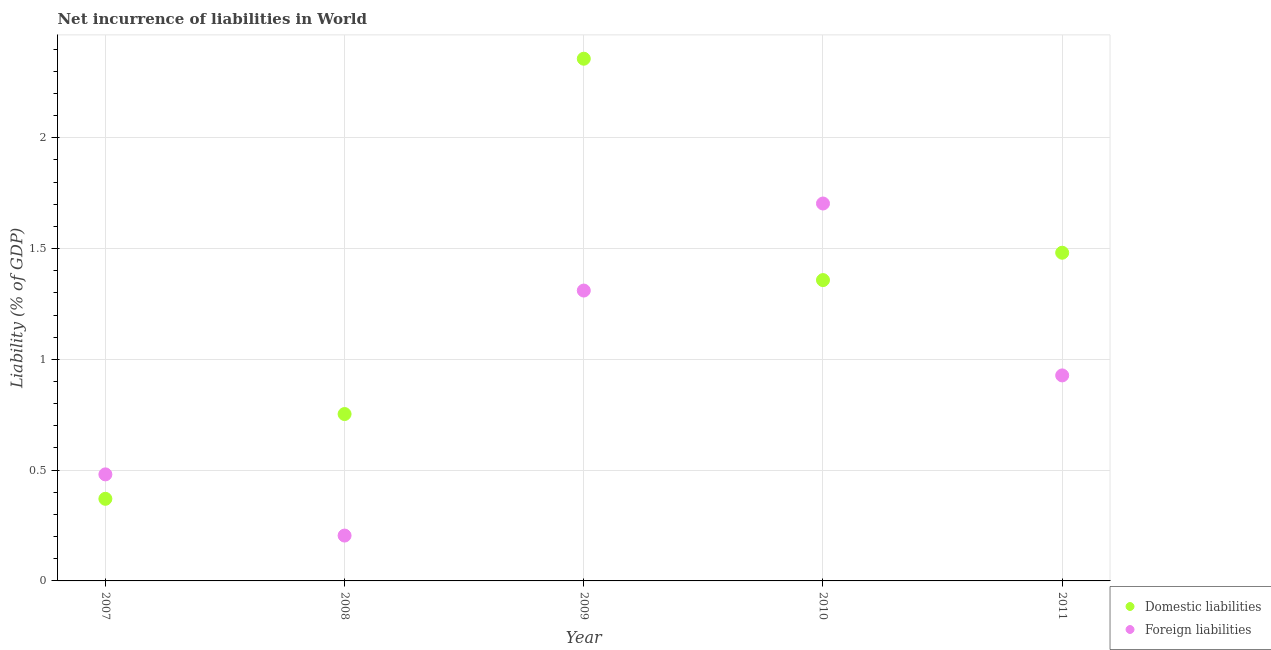What is the incurrence of domestic liabilities in 2010?
Provide a short and direct response. 1.36. Across all years, what is the maximum incurrence of foreign liabilities?
Provide a succinct answer. 1.7. Across all years, what is the minimum incurrence of domestic liabilities?
Your answer should be compact. 0.37. In which year was the incurrence of domestic liabilities minimum?
Keep it short and to the point. 2007. What is the total incurrence of foreign liabilities in the graph?
Give a very brief answer. 4.63. What is the difference between the incurrence of domestic liabilities in 2007 and that in 2010?
Offer a very short reply. -0.99. What is the difference between the incurrence of foreign liabilities in 2010 and the incurrence of domestic liabilities in 2008?
Your answer should be very brief. 0.95. What is the average incurrence of domestic liabilities per year?
Your answer should be very brief. 1.26. In the year 2011, what is the difference between the incurrence of domestic liabilities and incurrence of foreign liabilities?
Your answer should be very brief. 0.55. In how many years, is the incurrence of foreign liabilities greater than 2 %?
Offer a very short reply. 0. What is the ratio of the incurrence of domestic liabilities in 2007 to that in 2011?
Provide a succinct answer. 0.25. What is the difference between the highest and the second highest incurrence of foreign liabilities?
Your answer should be very brief. 0.39. What is the difference between the highest and the lowest incurrence of foreign liabilities?
Offer a terse response. 1.5. Is the sum of the incurrence of foreign liabilities in 2009 and 2011 greater than the maximum incurrence of domestic liabilities across all years?
Provide a succinct answer. No. Does the incurrence of foreign liabilities monotonically increase over the years?
Keep it short and to the point. No. How many dotlines are there?
Give a very brief answer. 2. How many years are there in the graph?
Make the answer very short. 5. Are the values on the major ticks of Y-axis written in scientific E-notation?
Provide a short and direct response. No. Does the graph contain any zero values?
Provide a succinct answer. No. Where does the legend appear in the graph?
Your response must be concise. Bottom right. How many legend labels are there?
Provide a succinct answer. 2. What is the title of the graph?
Make the answer very short. Net incurrence of liabilities in World. What is the label or title of the Y-axis?
Keep it short and to the point. Liability (% of GDP). What is the Liability (% of GDP) in Domestic liabilities in 2007?
Provide a succinct answer. 0.37. What is the Liability (% of GDP) in Foreign liabilities in 2007?
Keep it short and to the point. 0.48. What is the Liability (% of GDP) of Domestic liabilities in 2008?
Keep it short and to the point. 0.75. What is the Liability (% of GDP) in Foreign liabilities in 2008?
Offer a terse response. 0.2. What is the Liability (% of GDP) of Domestic liabilities in 2009?
Your answer should be very brief. 2.36. What is the Liability (% of GDP) in Foreign liabilities in 2009?
Your answer should be very brief. 1.31. What is the Liability (% of GDP) of Domestic liabilities in 2010?
Your response must be concise. 1.36. What is the Liability (% of GDP) of Foreign liabilities in 2010?
Your answer should be very brief. 1.7. What is the Liability (% of GDP) in Domestic liabilities in 2011?
Your response must be concise. 1.48. What is the Liability (% of GDP) of Foreign liabilities in 2011?
Make the answer very short. 0.93. Across all years, what is the maximum Liability (% of GDP) in Domestic liabilities?
Your answer should be compact. 2.36. Across all years, what is the maximum Liability (% of GDP) of Foreign liabilities?
Offer a very short reply. 1.7. Across all years, what is the minimum Liability (% of GDP) of Domestic liabilities?
Make the answer very short. 0.37. Across all years, what is the minimum Liability (% of GDP) in Foreign liabilities?
Give a very brief answer. 0.2. What is the total Liability (% of GDP) of Domestic liabilities in the graph?
Keep it short and to the point. 6.32. What is the total Liability (% of GDP) of Foreign liabilities in the graph?
Offer a very short reply. 4.63. What is the difference between the Liability (% of GDP) of Domestic liabilities in 2007 and that in 2008?
Offer a very short reply. -0.38. What is the difference between the Liability (% of GDP) in Foreign liabilities in 2007 and that in 2008?
Your answer should be very brief. 0.28. What is the difference between the Liability (% of GDP) of Domestic liabilities in 2007 and that in 2009?
Ensure brevity in your answer.  -1.99. What is the difference between the Liability (% of GDP) in Foreign liabilities in 2007 and that in 2009?
Offer a terse response. -0.83. What is the difference between the Liability (% of GDP) of Domestic liabilities in 2007 and that in 2010?
Offer a terse response. -0.99. What is the difference between the Liability (% of GDP) in Foreign liabilities in 2007 and that in 2010?
Give a very brief answer. -1.22. What is the difference between the Liability (% of GDP) of Domestic liabilities in 2007 and that in 2011?
Ensure brevity in your answer.  -1.11. What is the difference between the Liability (% of GDP) of Foreign liabilities in 2007 and that in 2011?
Provide a short and direct response. -0.45. What is the difference between the Liability (% of GDP) in Domestic liabilities in 2008 and that in 2009?
Your response must be concise. -1.6. What is the difference between the Liability (% of GDP) of Foreign liabilities in 2008 and that in 2009?
Provide a short and direct response. -1.11. What is the difference between the Liability (% of GDP) of Domestic liabilities in 2008 and that in 2010?
Your response must be concise. -0.6. What is the difference between the Liability (% of GDP) in Foreign liabilities in 2008 and that in 2010?
Your answer should be very brief. -1.5. What is the difference between the Liability (% of GDP) in Domestic liabilities in 2008 and that in 2011?
Offer a very short reply. -0.73. What is the difference between the Liability (% of GDP) in Foreign liabilities in 2008 and that in 2011?
Ensure brevity in your answer.  -0.72. What is the difference between the Liability (% of GDP) of Foreign liabilities in 2009 and that in 2010?
Your answer should be very brief. -0.39. What is the difference between the Liability (% of GDP) in Domestic liabilities in 2009 and that in 2011?
Give a very brief answer. 0.88. What is the difference between the Liability (% of GDP) in Foreign liabilities in 2009 and that in 2011?
Keep it short and to the point. 0.38. What is the difference between the Liability (% of GDP) in Domestic liabilities in 2010 and that in 2011?
Provide a succinct answer. -0.12. What is the difference between the Liability (% of GDP) in Foreign liabilities in 2010 and that in 2011?
Your answer should be compact. 0.78. What is the difference between the Liability (% of GDP) of Domestic liabilities in 2007 and the Liability (% of GDP) of Foreign liabilities in 2008?
Provide a succinct answer. 0.17. What is the difference between the Liability (% of GDP) of Domestic liabilities in 2007 and the Liability (% of GDP) of Foreign liabilities in 2009?
Your answer should be compact. -0.94. What is the difference between the Liability (% of GDP) of Domestic liabilities in 2007 and the Liability (% of GDP) of Foreign liabilities in 2010?
Your response must be concise. -1.33. What is the difference between the Liability (% of GDP) of Domestic liabilities in 2007 and the Liability (% of GDP) of Foreign liabilities in 2011?
Give a very brief answer. -0.56. What is the difference between the Liability (% of GDP) in Domestic liabilities in 2008 and the Liability (% of GDP) in Foreign liabilities in 2009?
Give a very brief answer. -0.56. What is the difference between the Liability (% of GDP) of Domestic liabilities in 2008 and the Liability (% of GDP) of Foreign liabilities in 2010?
Offer a terse response. -0.95. What is the difference between the Liability (% of GDP) in Domestic liabilities in 2008 and the Liability (% of GDP) in Foreign liabilities in 2011?
Provide a short and direct response. -0.17. What is the difference between the Liability (% of GDP) of Domestic liabilities in 2009 and the Liability (% of GDP) of Foreign liabilities in 2010?
Provide a short and direct response. 0.65. What is the difference between the Liability (% of GDP) of Domestic liabilities in 2009 and the Liability (% of GDP) of Foreign liabilities in 2011?
Make the answer very short. 1.43. What is the difference between the Liability (% of GDP) of Domestic liabilities in 2010 and the Liability (% of GDP) of Foreign liabilities in 2011?
Your response must be concise. 0.43. What is the average Liability (% of GDP) in Domestic liabilities per year?
Keep it short and to the point. 1.26. What is the average Liability (% of GDP) in Foreign liabilities per year?
Provide a succinct answer. 0.93. In the year 2007, what is the difference between the Liability (% of GDP) in Domestic liabilities and Liability (% of GDP) in Foreign liabilities?
Your response must be concise. -0.11. In the year 2008, what is the difference between the Liability (% of GDP) of Domestic liabilities and Liability (% of GDP) of Foreign liabilities?
Provide a short and direct response. 0.55. In the year 2009, what is the difference between the Liability (% of GDP) in Domestic liabilities and Liability (% of GDP) in Foreign liabilities?
Your response must be concise. 1.05. In the year 2010, what is the difference between the Liability (% of GDP) of Domestic liabilities and Liability (% of GDP) of Foreign liabilities?
Make the answer very short. -0.35. In the year 2011, what is the difference between the Liability (% of GDP) in Domestic liabilities and Liability (% of GDP) in Foreign liabilities?
Your answer should be very brief. 0.55. What is the ratio of the Liability (% of GDP) in Domestic liabilities in 2007 to that in 2008?
Keep it short and to the point. 0.49. What is the ratio of the Liability (% of GDP) of Foreign liabilities in 2007 to that in 2008?
Your answer should be very brief. 2.35. What is the ratio of the Liability (% of GDP) of Domestic liabilities in 2007 to that in 2009?
Your answer should be compact. 0.16. What is the ratio of the Liability (% of GDP) in Foreign liabilities in 2007 to that in 2009?
Provide a short and direct response. 0.37. What is the ratio of the Liability (% of GDP) in Domestic liabilities in 2007 to that in 2010?
Keep it short and to the point. 0.27. What is the ratio of the Liability (% of GDP) of Foreign liabilities in 2007 to that in 2010?
Offer a very short reply. 0.28. What is the ratio of the Liability (% of GDP) of Domestic liabilities in 2007 to that in 2011?
Ensure brevity in your answer.  0.25. What is the ratio of the Liability (% of GDP) in Foreign liabilities in 2007 to that in 2011?
Your answer should be compact. 0.52. What is the ratio of the Liability (% of GDP) of Domestic liabilities in 2008 to that in 2009?
Keep it short and to the point. 0.32. What is the ratio of the Liability (% of GDP) of Foreign liabilities in 2008 to that in 2009?
Give a very brief answer. 0.16. What is the ratio of the Liability (% of GDP) in Domestic liabilities in 2008 to that in 2010?
Offer a terse response. 0.55. What is the ratio of the Liability (% of GDP) in Foreign liabilities in 2008 to that in 2010?
Your response must be concise. 0.12. What is the ratio of the Liability (% of GDP) of Domestic liabilities in 2008 to that in 2011?
Your answer should be very brief. 0.51. What is the ratio of the Liability (% of GDP) in Foreign liabilities in 2008 to that in 2011?
Offer a terse response. 0.22. What is the ratio of the Liability (% of GDP) of Domestic liabilities in 2009 to that in 2010?
Offer a very short reply. 1.74. What is the ratio of the Liability (% of GDP) of Foreign liabilities in 2009 to that in 2010?
Offer a terse response. 0.77. What is the ratio of the Liability (% of GDP) in Domestic liabilities in 2009 to that in 2011?
Keep it short and to the point. 1.59. What is the ratio of the Liability (% of GDP) in Foreign liabilities in 2009 to that in 2011?
Make the answer very short. 1.41. What is the ratio of the Liability (% of GDP) of Domestic liabilities in 2010 to that in 2011?
Offer a terse response. 0.92. What is the ratio of the Liability (% of GDP) of Foreign liabilities in 2010 to that in 2011?
Your response must be concise. 1.84. What is the difference between the highest and the second highest Liability (% of GDP) of Domestic liabilities?
Ensure brevity in your answer.  0.88. What is the difference between the highest and the second highest Liability (% of GDP) of Foreign liabilities?
Your answer should be compact. 0.39. What is the difference between the highest and the lowest Liability (% of GDP) in Domestic liabilities?
Give a very brief answer. 1.99. What is the difference between the highest and the lowest Liability (% of GDP) in Foreign liabilities?
Your answer should be very brief. 1.5. 